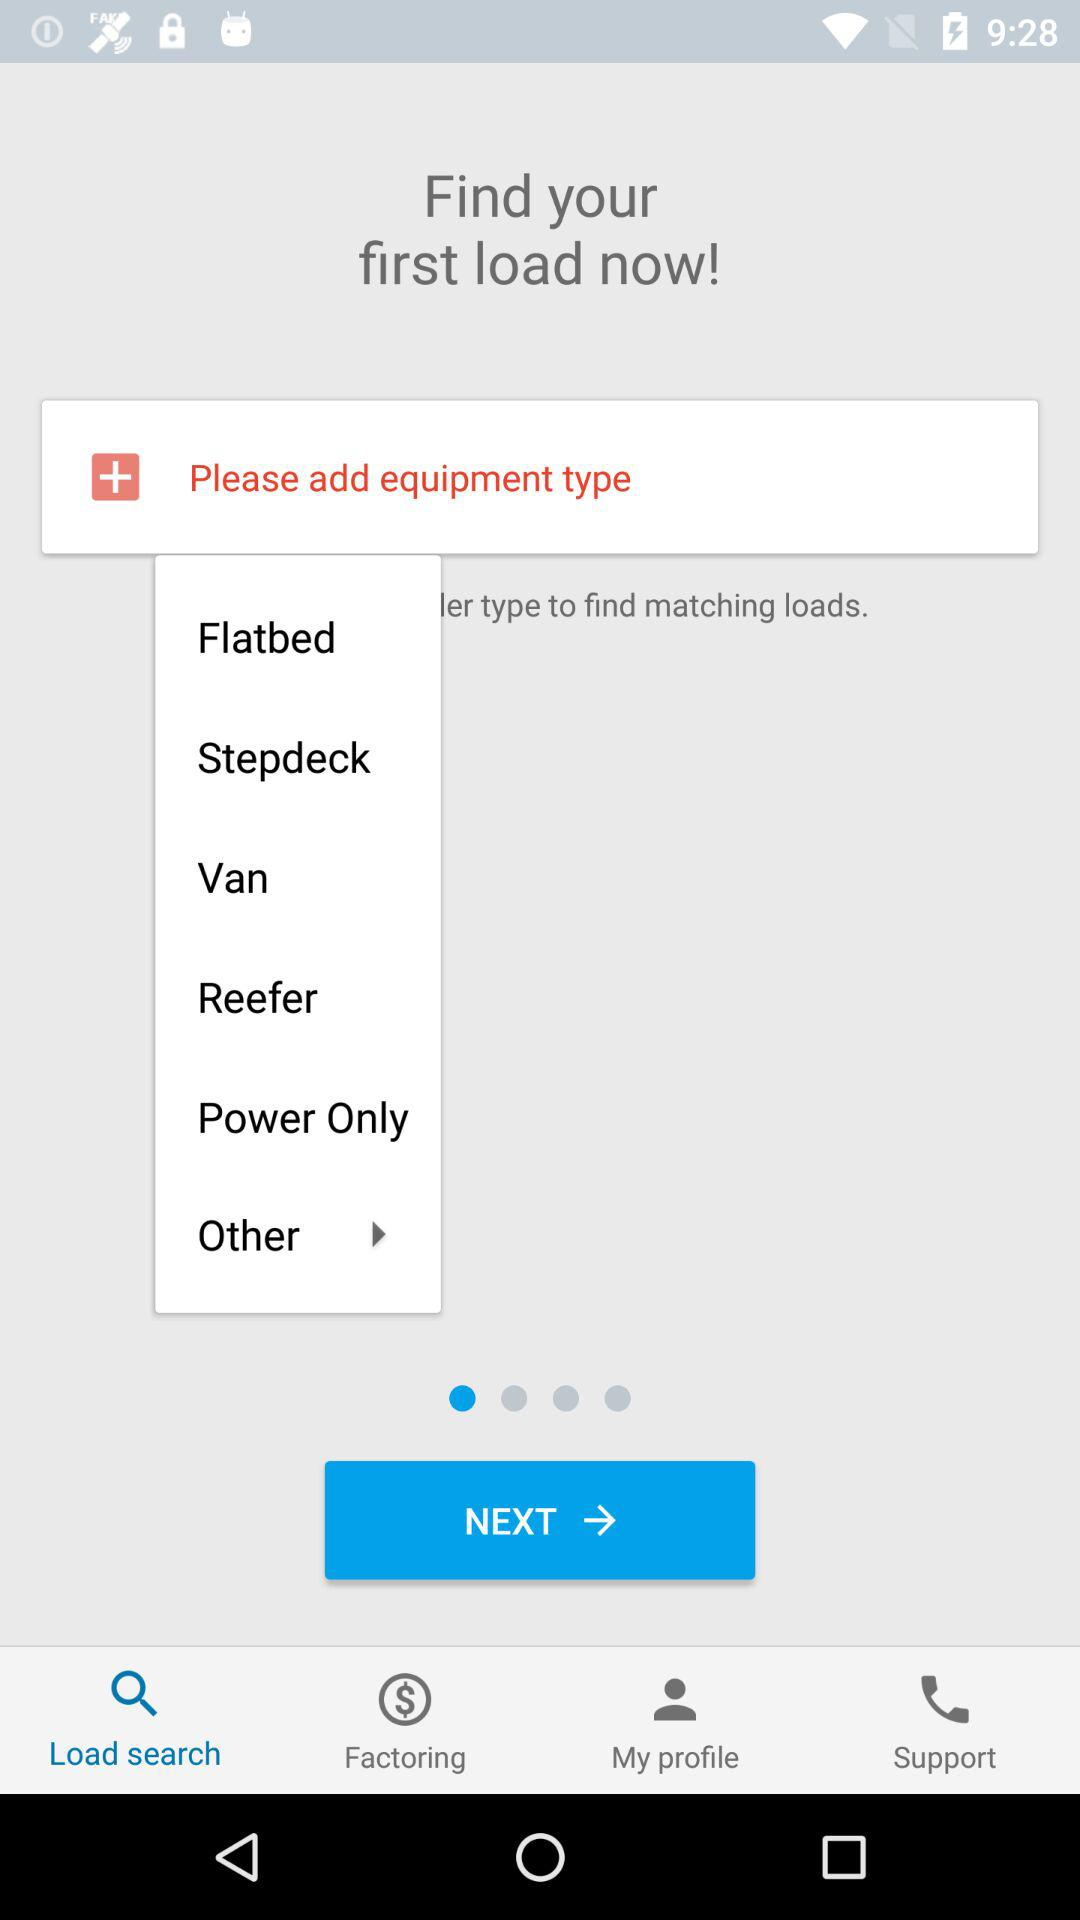What is the selected tab? The selected tab is "Load search". 